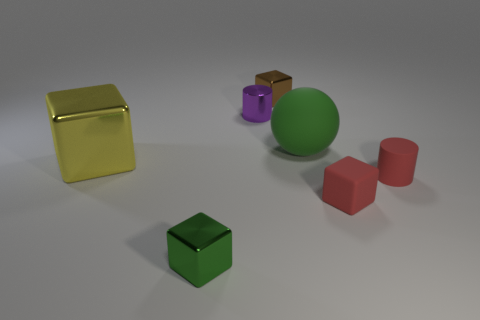What color is the object that is both on the right side of the tiny brown thing and behind the red matte cylinder?
Your response must be concise. Green. What number of small cylinders are the same color as the big rubber object?
Provide a succinct answer. 0. What number of blocks are small matte things or brown metal objects?
Keep it short and to the point. 2. The rubber cylinder that is the same size as the purple metallic cylinder is what color?
Your response must be concise. Red. Is there a rubber cylinder behind the tiny cube that is behind the small matte thing on the right side of the small red block?
Offer a terse response. No. How big is the green matte ball?
Make the answer very short. Large. How many things are either red rubber blocks or tiny green metal things?
Your answer should be very brief. 2. What color is the tiny cube that is the same material as the large green sphere?
Offer a very short reply. Red. There is a green shiny thing in front of the green ball; is it the same shape as the tiny brown metal thing?
Make the answer very short. Yes. How many objects are large objects left of the tiny green cube or red objects that are in front of the red cylinder?
Provide a short and direct response. 2. 